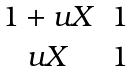Convert formula to latex. <formula><loc_0><loc_0><loc_500><loc_500>\begin{matrix} 1 + u X & 1 \\ u X & 1 \end{matrix}</formula> 